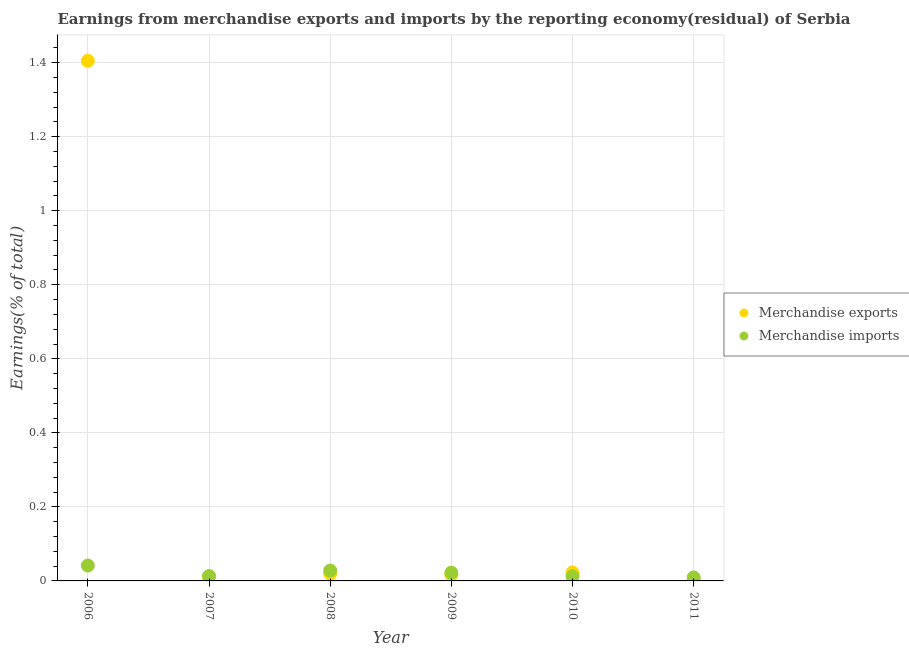How many different coloured dotlines are there?
Offer a very short reply. 2. Is the number of dotlines equal to the number of legend labels?
Your answer should be compact. Yes. What is the earnings from merchandise exports in 2007?
Offer a terse response. 0.01. Across all years, what is the maximum earnings from merchandise exports?
Offer a terse response. 1.4. Across all years, what is the minimum earnings from merchandise imports?
Provide a short and direct response. 0.01. What is the total earnings from merchandise exports in the graph?
Provide a succinct answer. 1.48. What is the difference between the earnings from merchandise exports in 2009 and that in 2011?
Keep it short and to the point. 0.01. What is the difference between the earnings from merchandise imports in 2006 and the earnings from merchandise exports in 2009?
Give a very brief answer. 0.03. What is the average earnings from merchandise exports per year?
Provide a succinct answer. 0.25. In the year 2009, what is the difference between the earnings from merchandise exports and earnings from merchandise imports?
Ensure brevity in your answer.  -0.01. In how many years, is the earnings from merchandise imports greater than 1.16 %?
Your answer should be compact. 0. What is the ratio of the earnings from merchandise imports in 2008 to that in 2010?
Provide a succinct answer. 2.22. Is the earnings from merchandise exports in 2007 less than that in 2009?
Offer a terse response. Yes. Is the difference between the earnings from merchandise imports in 2010 and 2011 greater than the difference between the earnings from merchandise exports in 2010 and 2011?
Offer a very short reply. No. What is the difference between the highest and the second highest earnings from merchandise exports?
Offer a terse response. 1.38. What is the difference between the highest and the lowest earnings from merchandise exports?
Make the answer very short. 1.4. In how many years, is the earnings from merchandise imports greater than the average earnings from merchandise imports taken over all years?
Give a very brief answer. 3. Is the earnings from merchandise exports strictly greater than the earnings from merchandise imports over the years?
Offer a very short reply. No. Is the earnings from merchandise exports strictly less than the earnings from merchandise imports over the years?
Give a very brief answer. No. How many dotlines are there?
Offer a terse response. 2. How many years are there in the graph?
Your answer should be very brief. 6. Does the graph contain grids?
Ensure brevity in your answer.  Yes. Where does the legend appear in the graph?
Ensure brevity in your answer.  Center right. How many legend labels are there?
Give a very brief answer. 2. How are the legend labels stacked?
Provide a succinct answer. Vertical. What is the title of the graph?
Make the answer very short. Earnings from merchandise exports and imports by the reporting economy(residual) of Serbia. Does "Quasi money growth" appear as one of the legend labels in the graph?
Your answer should be very brief. No. What is the label or title of the X-axis?
Your answer should be very brief. Year. What is the label or title of the Y-axis?
Make the answer very short. Earnings(% of total). What is the Earnings(% of total) in Merchandise exports in 2006?
Make the answer very short. 1.4. What is the Earnings(% of total) of Merchandise imports in 2006?
Keep it short and to the point. 0.04. What is the Earnings(% of total) of Merchandise exports in 2007?
Keep it short and to the point. 0.01. What is the Earnings(% of total) of Merchandise imports in 2007?
Keep it short and to the point. 0.01. What is the Earnings(% of total) of Merchandise exports in 2008?
Your response must be concise. 0.02. What is the Earnings(% of total) of Merchandise imports in 2008?
Offer a very short reply. 0.03. What is the Earnings(% of total) of Merchandise exports in 2009?
Offer a terse response. 0.02. What is the Earnings(% of total) of Merchandise imports in 2009?
Your answer should be very brief. 0.02. What is the Earnings(% of total) of Merchandise exports in 2010?
Ensure brevity in your answer.  0.02. What is the Earnings(% of total) of Merchandise imports in 2010?
Offer a terse response. 0.01. What is the Earnings(% of total) of Merchandise exports in 2011?
Offer a terse response. 0. What is the Earnings(% of total) in Merchandise imports in 2011?
Make the answer very short. 0.01. Across all years, what is the maximum Earnings(% of total) in Merchandise exports?
Provide a succinct answer. 1.4. Across all years, what is the maximum Earnings(% of total) in Merchandise imports?
Give a very brief answer. 0.04. Across all years, what is the minimum Earnings(% of total) in Merchandise exports?
Your answer should be compact. 0. Across all years, what is the minimum Earnings(% of total) in Merchandise imports?
Your response must be concise. 0.01. What is the total Earnings(% of total) of Merchandise exports in the graph?
Make the answer very short. 1.48. What is the total Earnings(% of total) in Merchandise imports in the graph?
Your answer should be very brief. 0.13. What is the difference between the Earnings(% of total) of Merchandise exports in 2006 and that in 2007?
Provide a short and direct response. 1.39. What is the difference between the Earnings(% of total) in Merchandise imports in 2006 and that in 2007?
Offer a terse response. 0.03. What is the difference between the Earnings(% of total) of Merchandise exports in 2006 and that in 2008?
Provide a short and direct response. 1.39. What is the difference between the Earnings(% of total) of Merchandise imports in 2006 and that in 2008?
Make the answer very short. 0.01. What is the difference between the Earnings(% of total) in Merchandise exports in 2006 and that in 2009?
Offer a terse response. 1.39. What is the difference between the Earnings(% of total) of Merchandise imports in 2006 and that in 2009?
Give a very brief answer. 0.02. What is the difference between the Earnings(% of total) in Merchandise exports in 2006 and that in 2010?
Provide a short and direct response. 1.38. What is the difference between the Earnings(% of total) in Merchandise imports in 2006 and that in 2010?
Your answer should be very brief. 0.03. What is the difference between the Earnings(% of total) in Merchandise exports in 2006 and that in 2011?
Provide a short and direct response. 1.4. What is the difference between the Earnings(% of total) in Merchandise imports in 2006 and that in 2011?
Your answer should be compact. 0.03. What is the difference between the Earnings(% of total) of Merchandise exports in 2007 and that in 2008?
Ensure brevity in your answer.  -0.01. What is the difference between the Earnings(% of total) of Merchandise imports in 2007 and that in 2008?
Provide a short and direct response. -0.01. What is the difference between the Earnings(% of total) in Merchandise exports in 2007 and that in 2009?
Offer a very short reply. -0. What is the difference between the Earnings(% of total) in Merchandise imports in 2007 and that in 2009?
Offer a very short reply. -0.01. What is the difference between the Earnings(% of total) in Merchandise exports in 2007 and that in 2010?
Make the answer very short. -0.01. What is the difference between the Earnings(% of total) in Merchandise exports in 2007 and that in 2011?
Ensure brevity in your answer.  0.01. What is the difference between the Earnings(% of total) in Merchandise imports in 2007 and that in 2011?
Your answer should be compact. 0. What is the difference between the Earnings(% of total) in Merchandise exports in 2008 and that in 2009?
Keep it short and to the point. 0. What is the difference between the Earnings(% of total) of Merchandise imports in 2008 and that in 2009?
Keep it short and to the point. 0.01. What is the difference between the Earnings(% of total) of Merchandise exports in 2008 and that in 2010?
Ensure brevity in your answer.  -0. What is the difference between the Earnings(% of total) in Merchandise imports in 2008 and that in 2010?
Give a very brief answer. 0.02. What is the difference between the Earnings(% of total) in Merchandise exports in 2008 and that in 2011?
Your answer should be compact. 0.02. What is the difference between the Earnings(% of total) in Merchandise imports in 2008 and that in 2011?
Offer a terse response. 0.02. What is the difference between the Earnings(% of total) in Merchandise exports in 2009 and that in 2010?
Keep it short and to the point. -0.01. What is the difference between the Earnings(% of total) of Merchandise imports in 2009 and that in 2010?
Offer a terse response. 0.01. What is the difference between the Earnings(% of total) of Merchandise exports in 2009 and that in 2011?
Your response must be concise. 0.01. What is the difference between the Earnings(% of total) in Merchandise imports in 2009 and that in 2011?
Your answer should be compact. 0.01. What is the difference between the Earnings(% of total) of Merchandise exports in 2010 and that in 2011?
Provide a succinct answer. 0.02. What is the difference between the Earnings(% of total) of Merchandise imports in 2010 and that in 2011?
Your answer should be compact. 0. What is the difference between the Earnings(% of total) in Merchandise exports in 2006 and the Earnings(% of total) in Merchandise imports in 2007?
Offer a terse response. 1.39. What is the difference between the Earnings(% of total) of Merchandise exports in 2006 and the Earnings(% of total) of Merchandise imports in 2008?
Provide a succinct answer. 1.38. What is the difference between the Earnings(% of total) of Merchandise exports in 2006 and the Earnings(% of total) of Merchandise imports in 2009?
Keep it short and to the point. 1.38. What is the difference between the Earnings(% of total) in Merchandise exports in 2006 and the Earnings(% of total) in Merchandise imports in 2010?
Ensure brevity in your answer.  1.39. What is the difference between the Earnings(% of total) of Merchandise exports in 2006 and the Earnings(% of total) of Merchandise imports in 2011?
Keep it short and to the point. 1.4. What is the difference between the Earnings(% of total) in Merchandise exports in 2007 and the Earnings(% of total) in Merchandise imports in 2008?
Make the answer very short. -0.02. What is the difference between the Earnings(% of total) in Merchandise exports in 2007 and the Earnings(% of total) in Merchandise imports in 2009?
Your answer should be very brief. -0.01. What is the difference between the Earnings(% of total) in Merchandise exports in 2007 and the Earnings(% of total) in Merchandise imports in 2010?
Offer a terse response. -0. What is the difference between the Earnings(% of total) in Merchandise exports in 2007 and the Earnings(% of total) in Merchandise imports in 2011?
Offer a terse response. 0. What is the difference between the Earnings(% of total) in Merchandise exports in 2008 and the Earnings(% of total) in Merchandise imports in 2009?
Keep it short and to the point. -0. What is the difference between the Earnings(% of total) in Merchandise exports in 2008 and the Earnings(% of total) in Merchandise imports in 2010?
Make the answer very short. 0.01. What is the difference between the Earnings(% of total) in Merchandise exports in 2008 and the Earnings(% of total) in Merchandise imports in 2011?
Your answer should be very brief. 0.01. What is the difference between the Earnings(% of total) of Merchandise exports in 2009 and the Earnings(% of total) of Merchandise imports in 2010?
Keep it short and to the point. 0. What is the difference between the Earnings(% of total) in Merchandise exports in 2009 and the Earnings(% of total) in Merchandise imports in 2011?
Offer a very short reply. 0.01. What is the difference between the Earnings(% of total) in Merchandise exports in 2010 and the Earnings(% of total) in Merchandise imports in 2011?
Your response must be concise. 0.01. What is the average Earnings(% of total) of Merchandise exports per year?
Provide a succinct answer. 0.25. What is the average Earnings(% of total) of Merchandise imports per year?
Keep it short and to the point. 0.02. In the year 2006, what is the difference between the Earnings(% of total) of Merchandise exports and Earnings(% of total) of Merchandise imports?
Give a very brief answer. 1.36. In the year 2007, what is the difference between the Earnings(% of total) in Merchandise exports and Earnings(% of total) in Merchandise imports?
Make the answer very short. -0. In the year 2008, what is the difference between the Earnings(% of total) in Merchandise exports and Earnings(% of total) in Merchandise imports?
Give a very brief answer. -0.01. In the year 2009, what is the difference between the Earnings(% of total) in Merchandise exports and Earnings(% of total) in Merchandise imports?
Provide a short and direct response. -0.01. In the year 2010, what is the difference between the Earnings(% of total) in Merchandise exports and Earnings(% of total) in Merchandise imports?
Provide a succinct answer. 0.01. In the year 2011, what is the difference between the Earnings(% of total) of Merchandise exports and Earnings(% of total) of Merchandise imports?
Make the answer very short. -0.01. What is the ratio of the Earnings(% of total) in Merchandise exports in 2006 to that in 2007?
Give a very brief answer. 122.89. What is the ratio of the Earnings(% of total) in Merchandise imports in 2006 to that in 2007?
Provide a short and direct response. 3.19. What is the ratio of the Earnings(% of total) of Merchandise exports in 2006 to that in 2008?
Give a very brief answer. 71.45. What is the ratio of the Earnings(% of total) of Merchandise imports in 2006 to that in 2008?
Give a very brief answer. 1.48. What is the ratio of the Earnings(% of total) of Merchandise exports in 2006 to that in 2009?
Offer a very short reply. 88.57. What is the ratio of the Earnings(% of total) of Merchandise imports in 2006 to that in 2009?
Provide a succinct answer. 1.86. What is the ratio of the Earnings(% of total) of Merchandise exports in 2006 to that in 2010?
Give a very brief answer. 61.07. What is the ratio of the Earnings(% of total) of Merchandise imports in 2006 to that in 2010?
Provide a succinct answer. 3.29. What is the ratio of the Earnings(% of total) of Merchandise exports in 2006 to that in 2011?
Your response must be concise. 526.08. What is the ratio of the Earnings(% of total) of Merchandise imports in 2006 to that in 2011?
Your answer should be very brief. 4.42. What is the ratio of the Earnings(% of total) in Merchandise exports in 2007 to that in 2008?
Ensure brevity in your answer.  0.58. What is the ratio of the Earnings(% of total) of Merchandise imports in 2007 to that in 2008?
Give a very brief answer. 0.46. What is the ratio of the Earnings(% of total) in Merchandise exports in 2007 to that in 2009?
Your answer should be compact. 0.72. What is the ratio of the Earnings(% of total) in Merchandise imports in 2007 to that in 2009?
Your answer should be compact. 0.58. What is the ratio of the Earnings(% of total) of Merchandise exports in 2007 to that in 2010?
Keep it short and to the point. 0.5. What is the ratio of the Earnings(% of total) in Merchandise imports in 2007 to that in 2010?
Ensure brevity in your answer.  1.03. What is the ratio of the Earnings(% of total) in Merchandise exports in 2007 to that in 2011?
Give a very brief answer. 4.28. What is the ratio of the Earnings(% of total) of Merchandise imports in 2007 to that in 2011?
Keep it short and to the point. 1.39. What is the ratio of the Earnings(% of total) in Merchandise exports in 2008 to that in 2009?
Offer a terse response. 1.24. What is the ratio of the Earnings(% of total) of Merchandise imports in 2008 to that in 2009?
Keep it short and to the point. 1.26. What is the ratio of the Earnings(% of total) of Merchandise exports in 2008 to that in 2010?
Provide a succinct answer. 0.85. What is the ratio of the Earnings(% of total) in Merchandise imports in 2008 to that in 2010?
Offer a very short reply. 2.22. What is the ratio of the Earnings(% of total) in Merchandise exports in 2008 to that in 2011?
Keep it short and to the point. 7.36. What is the ratio of the Earnings(% of total) of Merchandise imports in 2008 to that in 2011?
Keep it short and to the point. 2.99. What is the ratio of the Earnings(% of total) of Merchandise exports in 2009 to that in 2010?
Your answer should be compact. 0.69. What is the ratio of the Earnings(% of total) of Merchandise imports in 2009 to that in 2010?
Your answer should be compact. 1.77. What is the ratio of the Earnings(% of total) of Merchandise exports in 2009 to that in 2011?
Your answer should be compact. 5.94. What is the ratio of the Earnings(% of total) in Merchandise imports in 2009 to that in 2011?
Provide a short and direct response. 2.37. What is the ratio of the Earnings(% of total) in Merchandise exports in 2010 to that in 2011?
Keep it short and to the point. 8.61. What is the ratio of the Earnings(% of total) in Merchandise imports in 2010 to that in 2011?
Keep it short and to the point. 1.34. What is the difference between the highest and the second highest Earnings(% of total) in Merchandise exports?
Provide a succinct answer. 1.38. What is the difference between the highest and the second highest Earnings(% of total) of Merchandise imports?
Give a very brief answer. 0.01. What is the difference between the highest and the lowest Earnings(% of total) in Merchandise exports?
Ensure brevity in your answer.  1.4. What is the difference between the highest and the lowest Earnings(% of total) in Merchandise imports?
Offer a very short reply. 0.03. 